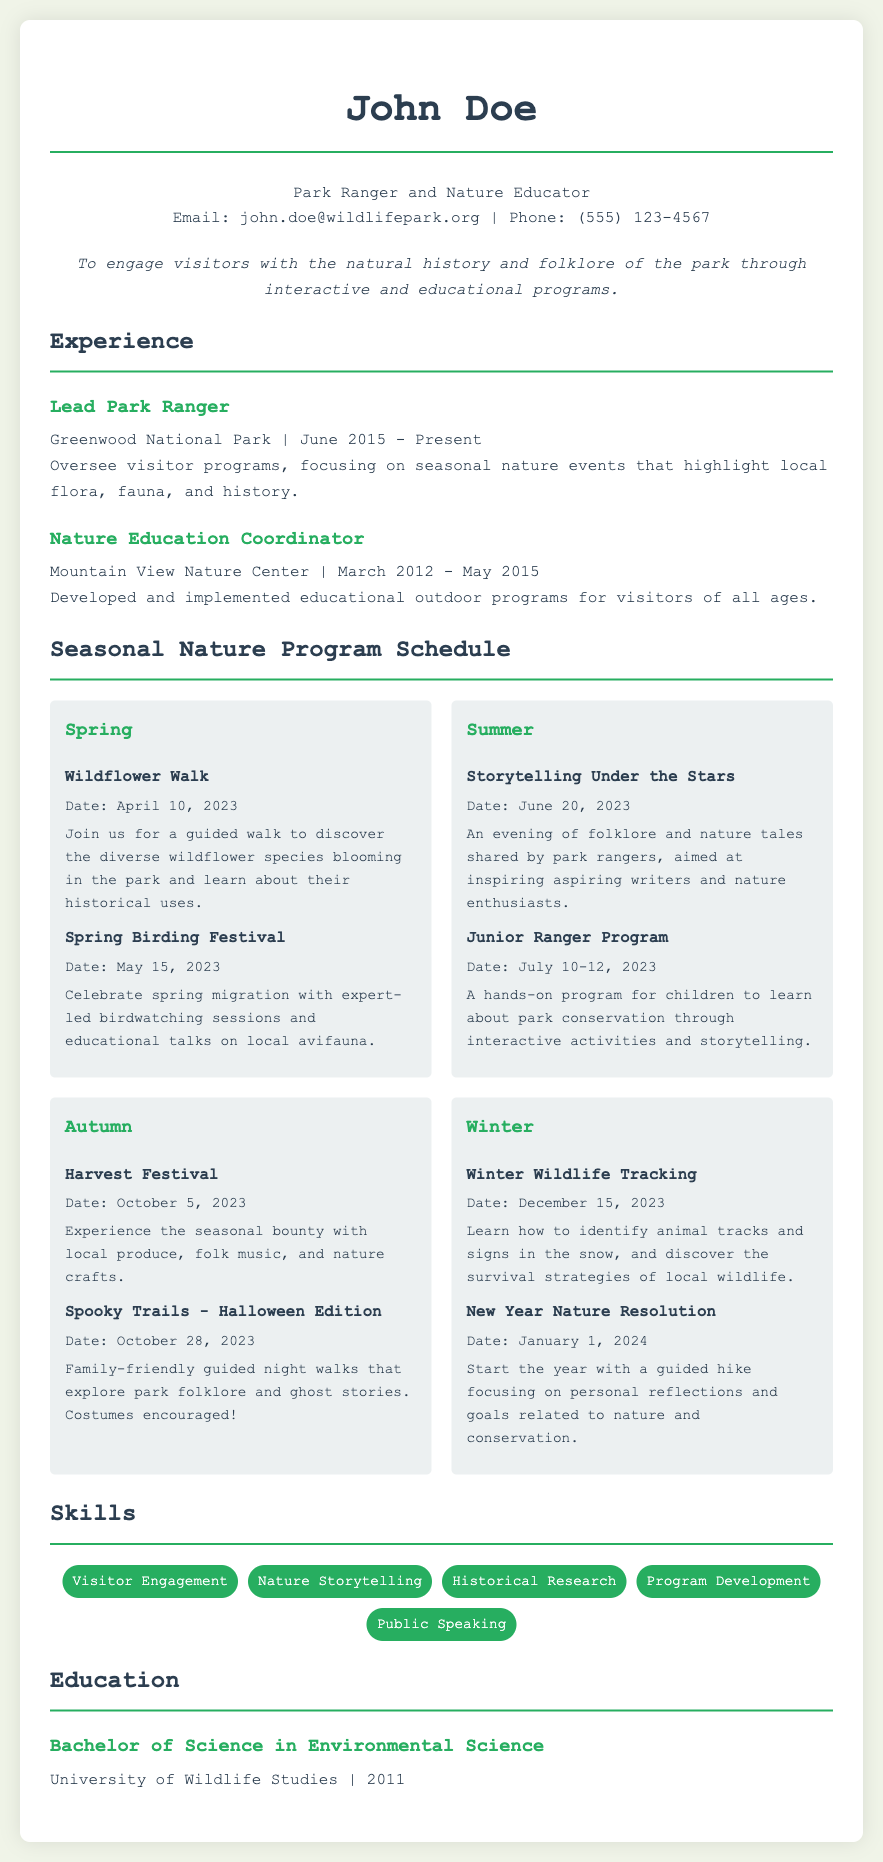what is the name of the park ranger? The document lists the name of the park ranger as John Doe.
Answer: John Doe what is the email address provided? The provided contact email for John Doe is john.doe@wildlifepark.org.
Answer: john.doe@wildlifepark.org when is the Winter Wildlife Tracking event? The date for the Winter Wildlife Tracking event is December 15, 2023.
Answer: December 15, 2023 what program is scheduled for July 10-12, 2023? The program scheduled for those dates is the Junior Ranger Program.
Answer: Junior Ranger Program which event focuses on local folklore? The event titled "Spooky Trails - Halloween Edition" focuses on local folklore.
Answer: Spooky Trails - Halloween Edition how many years of experience does John Doe have as a Lead Park Ranger? John Doe has been a Lead Park Ranger since June 2015, which amounts to approximately 8 years by 2023.
Answer: 8 years what type of program is the Storytelling Under the Stars? The program is characterized as an evening of folklore and nature tales.
Answer: evening of folklore and nature tales where did John Doe obtain his degree? John Doe earned his degree from the University of Wildlife Studies.
Answer: University of Wildlife Studies what is one of the skills mentioned in the document? One of the skills listed in the document is Visitor Engagement.
Answer: Visitor Engagement 